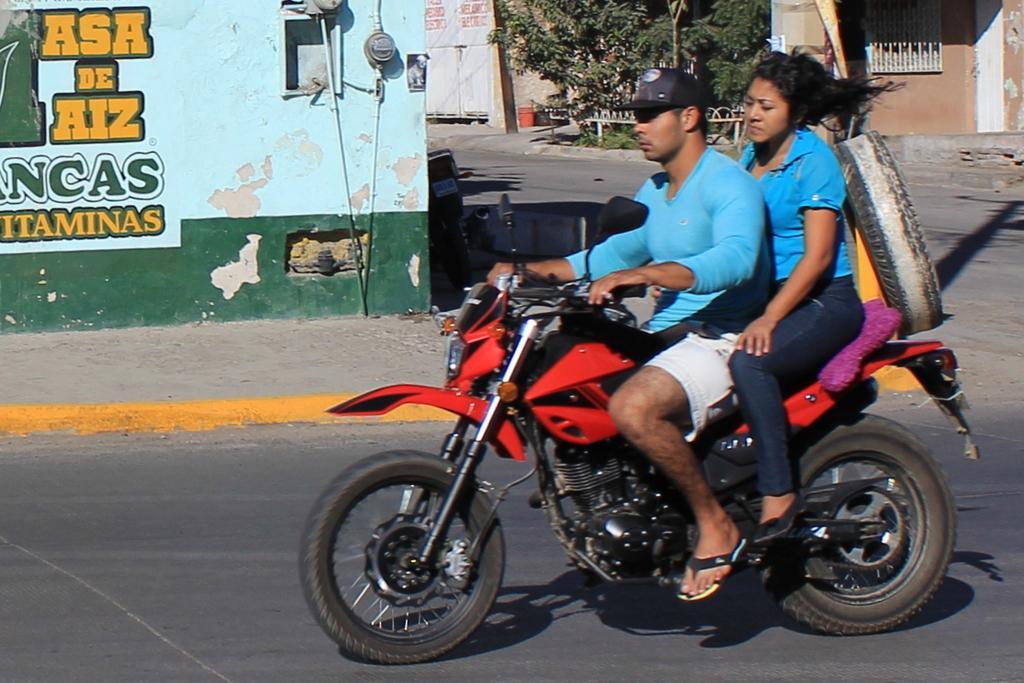In one or two sentences, can you explain what this image depicts? The person wearing a short is riding a red bike and the other lady who is wearing a blue shirt is sitting behind him and there's also something written on the wall beside them. 